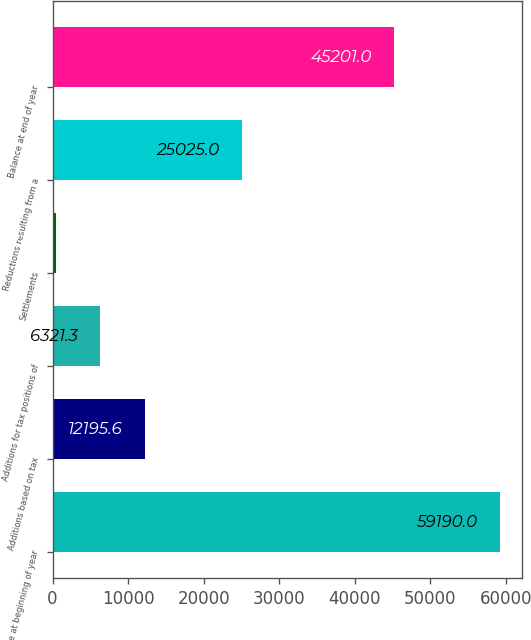Convert chart. <chart><loc_0><loc_0><loc_500><loc_500><bar_chart><fcel>Balance at beginning of year<fcel>Additions based on tax<fcel>Additions for tax positions of<fcel>Settlements<fcel>Reductions resulting from a<fcel>Balance at end of year<nl><fcel>59190<fcel>12195.6<fcel>6321.3<fcel>447<fcel>25025<fcel>45201<nl></chart> 